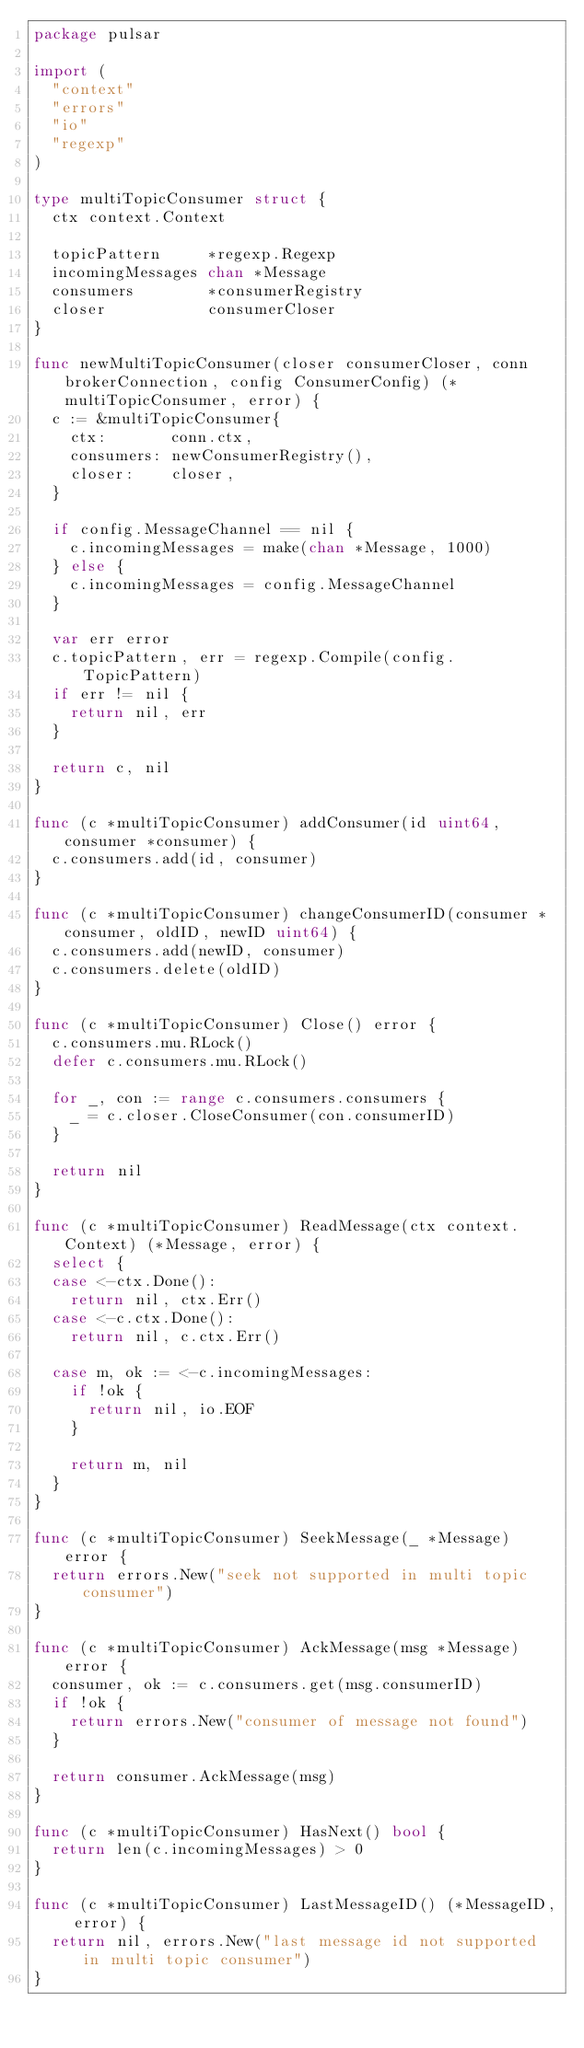Convert code to text. <code><loc_0><loc_0><loc_500><loc_500><_Go_>package pulsar

import (
	"context"
	"errors"
	"io"
	"regexp"
)

type multiTopicConsumer struct {
	ctx context.Context

	topicPattern     *regexp.Regexp
	incomingMessages chan *Message
	consumers        *consumerRegistry
	closer           consumerCloser
}

func newMultiTopicConsumer(closer consumerCloser, conn brokerConnection, config ConsumerConfig) (*multiTopicConsumer, error) {
	c := &multiTopicConsumer{
		ctx:       conn.ctx,
		consumers: newConsumerRegistry(),
		closer:    closer,
	}

	if config.MessageChannel == nil {
		c.incomingMessages = make(chan *Message, 1000)
	} else {
		c.incomingMessages = config.MessageChannel
	}

	var err error
	c.topicPattern, err = regexp.Compile(config.TopicPattern)
	if err != nil {
		return nil, err
	}

	return c, nil
}

func (c *multiTopicConsumer) addConsumer(id uint64, consumer *consumer) {
	c.consumers.add(id, consumer)
}

func (c *multiTopicConsumer) changeConsumerID(consumer *consumer, oldID, newID uint64) {
	c.consumers.add(newID, consumer)
	c.consumers.delete(oldID)
}

func (c *multiTopicConsumer) Close() error {
	c.consumers.mu.RLock()
	defer c.consumers.mu.RLock()

	for _, con := range c.consumers.consumers {
		_ = c.closer.CloseConsumer(con.consumerID)
	}

	return nil
}

func (c *multiTopicConsumer) ReadMessage(ctx context.Context) (*Message, error) {
	select {
	case <-ctx.Done():
		return nil, ctx.Err()
	case <-c.ctx.Done():
		return nil, c.ctx.Err()

	case m, ok := <-c.incomingMessages:
		if !ok {
			return nil, io.EOF
		}

		return m, nil
	}
}

func (c *multiTopicConsumer) SeekMessage(_ *Message) error {
	return errors.New("seek not supported in multi topic consumer")
}

func (c *multiTopicConsumer) AckMessage(msg *Message) error {
	consumer, ok := c.consumers.get(msg.consumerID)
	if !ok {
		return errors.New("consumer of message not found")
	}

	return consumer.AckMessage(msg)
}

func (c *multiTopicConsumer) HasNext() bool {
	return len(c.incomingMessages) > 0
}

func (c *multiTopicConsumer) LastMessageID() (*MessageID, error) {
	return nil, errors.New("last message id not supported in multi topic consumer")
}
</code> 